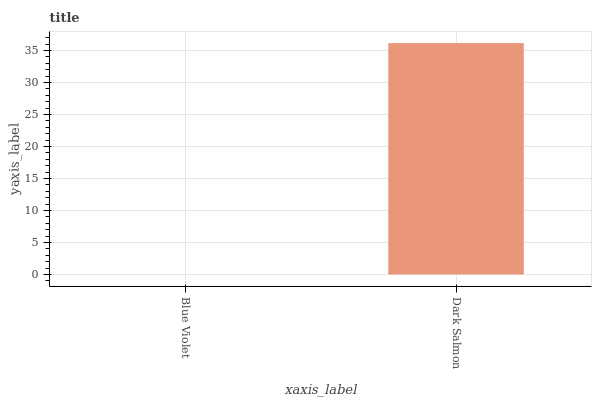Is Blue Violet the minimum?
Answer yes or no. Yes. Is Dark Salmon the maximum?
Answer yes or no. Yes. Is Dark Salmon the minimum?
Answer yes or no. No. Is Dark Salmon greater than Blue Violet?
Answer yes or no. Yes. Is Blue Violet less than Dark Salmon?
Answer yes or no. Yes. Is Blue Violet greater than Dark Salmon?
Answer yes or no. No. Is Dark Salmon less than Blue Violet?
Answer yes or no. No. Is Dark Salmon the high median?
Answer yes or no. Yes. Is Blue Violet the low median?
Answer yes or no. Yes. Is Blue Violet the high median?
Answer yes or no. No. Is Dark Salmon the low median?
Answer yes or no. No. 